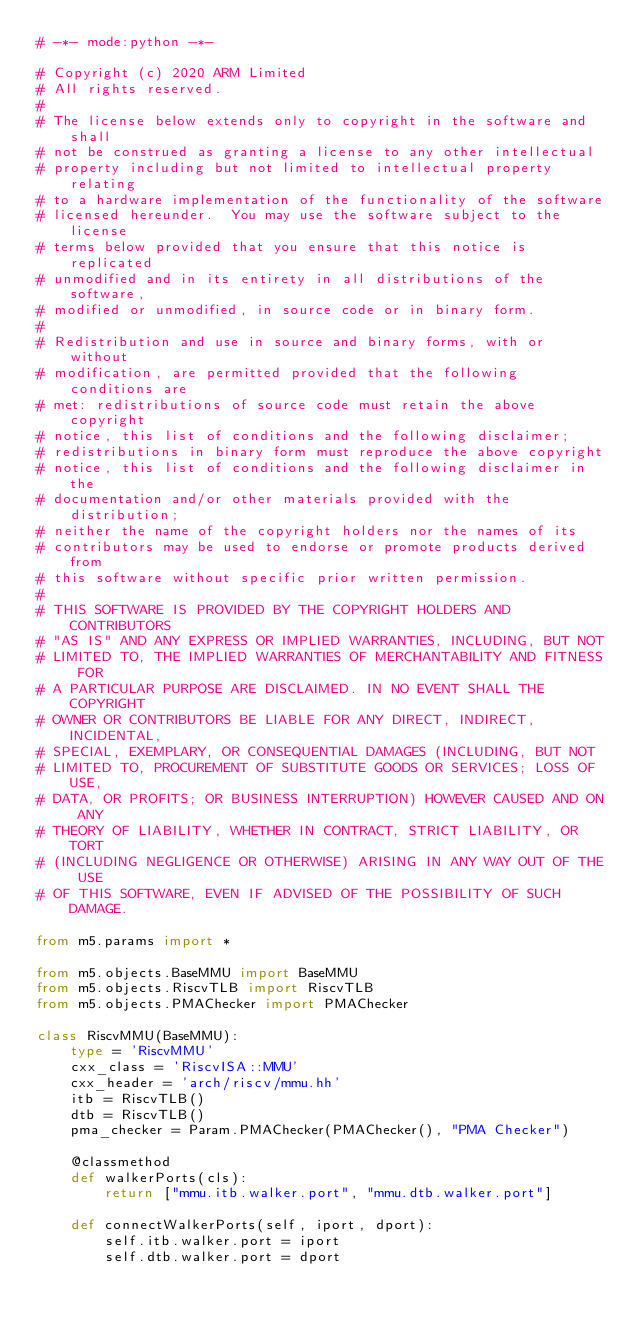<code> <loc_0><loc_0><loc_500><loc_500><_Python_># -*- mode:python -*-

# Copyright (c) 2020 ARM Limited
# All rights reserved.
#
# The license below extends only to copyright in the software and shall
# not be construed as granting a license to any other intellectual
# property including but not limited to intellectual property relating
# to a hardware implementation of the functionality of the software
# licensed hereunder.  You may use the software subject to the license
# terms below provided that you ensure that this notice is replicated
# unmodified and in its entirety in all distributions of the software,
# modified or unmodified, in source code or in binary form.
#
# Redistribution and use in source and binary forms, with or without
# modification, are permitted provided that the following conditions are
# met: redistributions of source code must retain the above copyright
# notice, this list of conditions and the following disclaimer;
# redistributions in binary form must reproduce the above copyright
# notice, this list of conditions and the following disclaimer in the
# documentation and/or other materials provided with the distribution;
# neither the name of the copyright holders nor the names of its
# contributors may be used to endorse or promote products derived from
# this software without specific prior written permission.
#
# THIS SOFTWARE IS PROVIDED BY THE COPYRIGHT HOLDERS AND CONTRIBUTORS
# "AS IS" AND ANY EXPRESS OR IMPLIED WARRANTIES, INCLUDING, BUT NOT
# LIMITED TO, THE IMPLIED WARRANTIES OF MERCHANTABILITY AND FITNESS FOR
# A PARTICULAR PURPOSE ARE DISCLAIMED. IN NO EVENT SHALL THE COPYRIGHT
# OWNER OR CONTRIBUTORS BE LIABLE FOR ANY DIRECT, INDIRECT, INCIDENTAL,
# SPECIAL, EXEMPLARY, OR CONSEQUENTIAL DAMAGES (INCLUDING, BUT NOT
# LIMITED TO, PROCUREMENT OF SUBSTITUTE GOODS OR SERVICES; LOSS OF USE,
# DATA, OR PROFITS; OR BUSINESS INTERRUPTION) HOWEVER CAUSED AND ON ANY
# THEORY OF LIABILITY, WHETHER IN CONTRACT, STRICT LIABILITY, OR TORT
# (INCLUDING NEGLIGENCE OR OTHERWISE) ARISING IN ANY WAY OUT OF THE USE
# OF THIS SOFTWARE, EVEN IF ADVISED OF THE POSSIBILITY OF SUCH DAMAGE.

from m5.params import *

from m5.objects.BaseMMU import BaseMMU
from m5.objects.RiscvTLB import RiscvTLB
from m5.objects.PMAChecker import PMAChecker

class RiscvMMU(BaseMMU):
    type = 'RiscvMMU'
    cxx_class = 'RiscvISA::MMU'
    cxx_header = 'arch/riscv/mmu.hh'
    itb = RiscvTLB()
    dtb = RiscvTLB()
    pma_checker = Param.PMAChecker(PMAChecker(), "PMA Checker")

    @classmethod
    def walkerPorts(cls):
        return ["mmu.itb.walker.port", "mmu.dtb.walker.port"]

    def connectWalkerPorts(self, iport, dport):
        self.itb.walker.port = iport
        self.dtb.walker.port = dport
</code> 